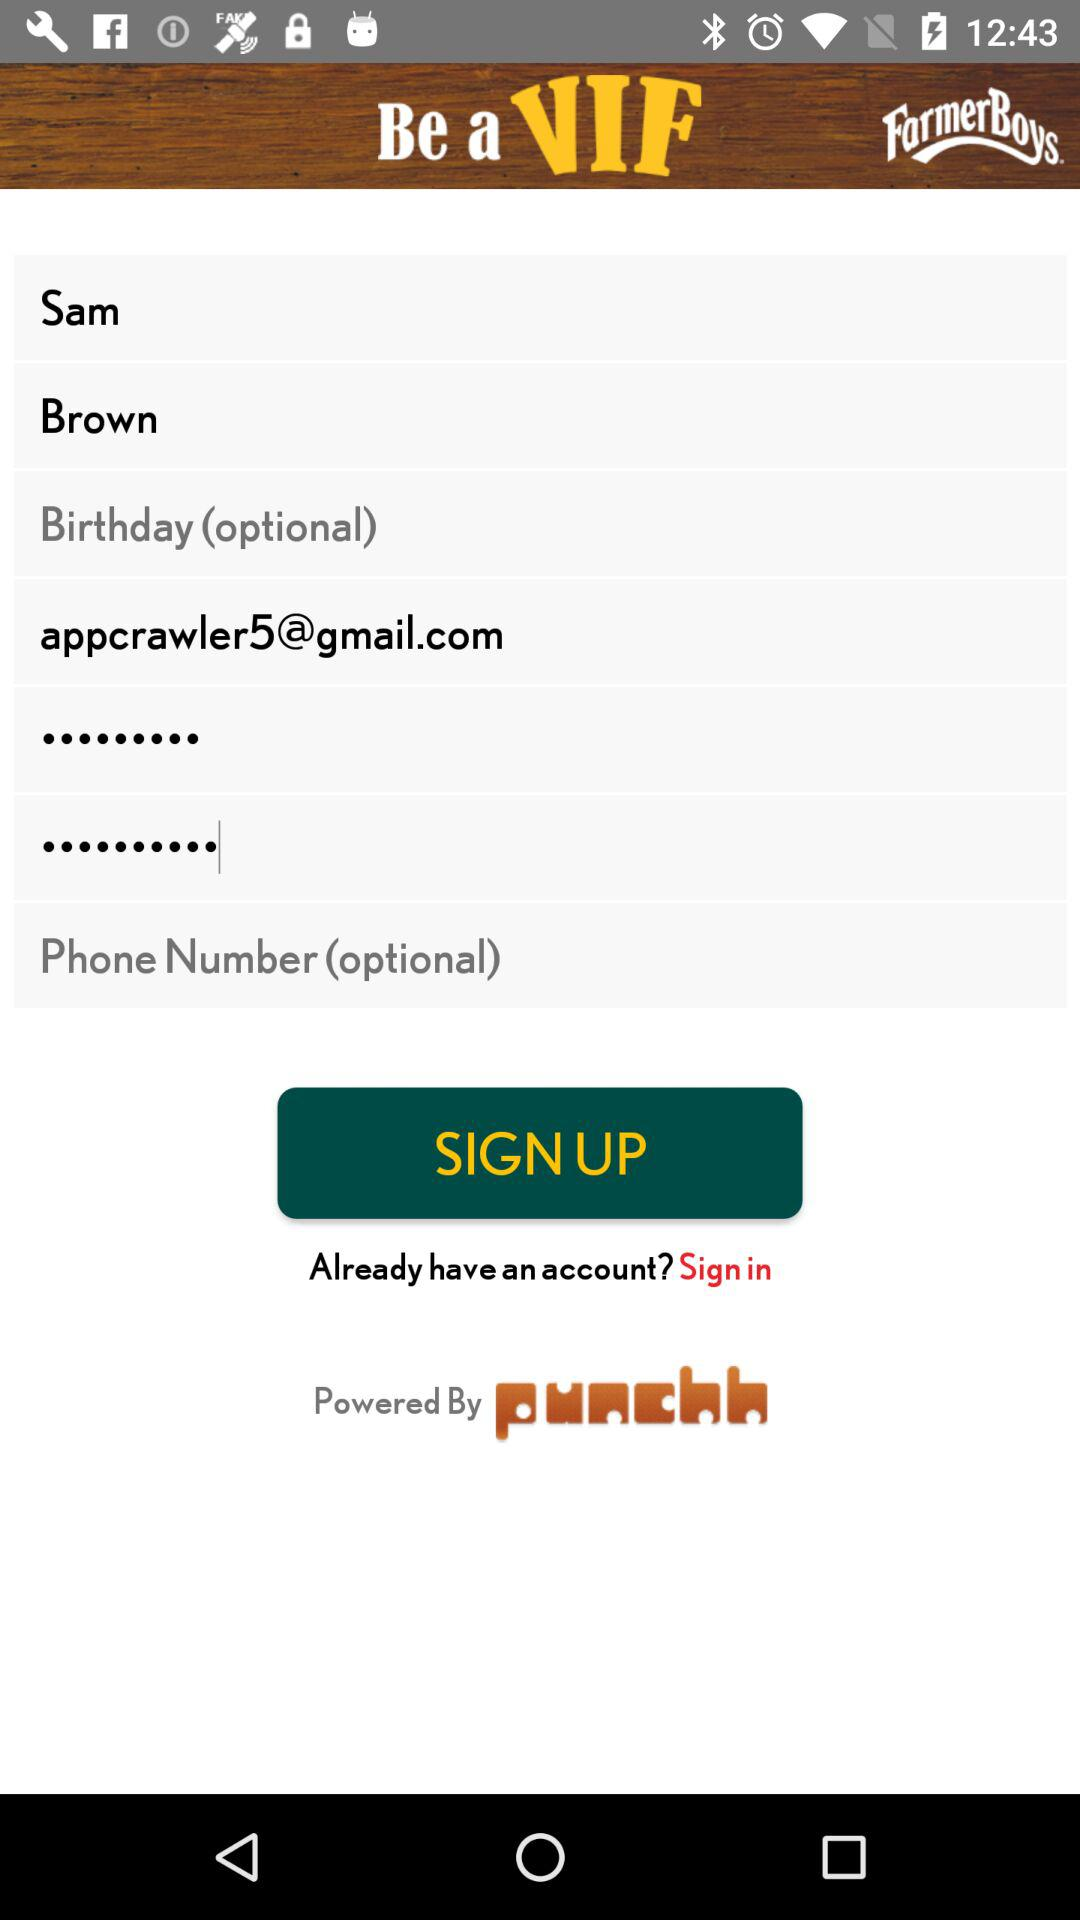What is the given Gmail ID? The Gmail ID is appcrawler5@gmail.com. 